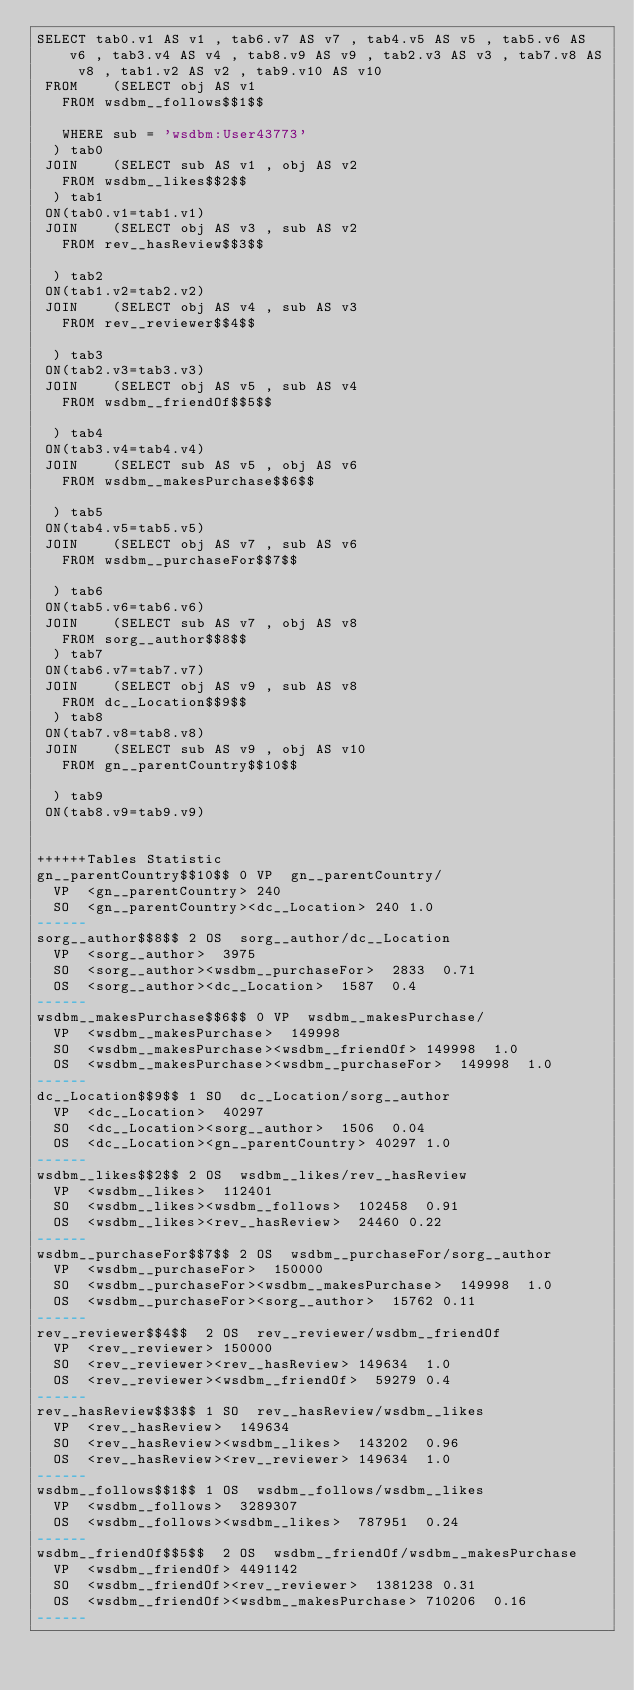<code> <loc_0><loc_0><loc_500><loc_500><_SQL_>SELECT tab0.v1 AS v1 , tab6.v7 AS v7 , tab4.v5 AS v5 , tab5.v6 AS v6 , tab3.v4 AS v4 , tab8.v9 AS v9 , tab2.v3 AS v3 , tab7.v8 AS v8 , tab1.v2 AS v2 , tab9.v10 AS v10 
 FROM    (SELECT obj AS v1 
	 FROM wsdbm__follows$$1$$
	 
	 WHERE sub = 'wsdbm:User43773'
	) tab0
 JOIN    (SELECT sub AS v1 , obj AS v2 
	 FROM wsdbm__likes$$2$$
	) tab1
 ON(tab0.v1=tab1.v1)
 JOIN    (SELECT obj AS v3 , sub AS v2 
	 FROM rev__hasReview$$3$$
	
	) tab2
 ON(tab1.v2=tab2.v2)
 JOIN    (SELECT obj AS v4 , sub AS v3 
	 FROM rev__reviewer$$4$$
	
	) tab3
 ON(tab2.v3=tab3.v3)
 JOIN    (SELECT obj AS v5 , sub AS v4 
	 FROM wsdbm__friendOf$$5$$
	
	) tab4
 ON(tab3.v4=tab4.v4)
 JOIN    (SELECT sub AS v5 , obj AS v6 
	 FROM wsdbm__makesPurchase$$6$$
	
	) tab5
 ON(tab4.v5=tab5.v5)
 JOIN    (SELECT obj AS v7 , sub AS v6 
	 FROM wsdbm__purchaseFor$$7$$
	
	) tab6
 ON(tab5.v6=tab6.v6)
 JOIN    (SELECT sub AS v7 , obj AS v8 
	 FROM sorg__author$$8$$
	) tab7
 ON(tab6.v7=tab7.v7)
 JOIN    (SELECT obj AS v9 , sub AS v8 
	 FROM dc__Location$$9$$
	) tab8
 ON(tab7.v8=tab8.v8)
 JOIN    (SELECT sub AS v9 , obj AS v10 
	 FROM gn__parentCountry$$10$$
	
	) tab9
 ON(tab8.v9=tab9.v9)


++++++Tables Statistic
gn__parentCountry$$10$$	0	VP	gn__parentCountry/
	VP	<gn__parentCountry>	240
	SO	<gn__parentCountry><dc__Location>	240	1.0
------
sorg__author$$8$$	2	OS	sorg__author/dc__Location
	VP	<sorg__author>	3975
	SO	<sorg__author><wsdbm__purchaseFor>	2833	0.71
	OS	<sorg__author><dc__Location>	1587	0.4
------
wsdbm__makesPurchase$$6$$	0	VP	wsdbm__makesPurchase/
	VP	<wsdbm__makesPurchase>	149998
	SO	<wsdbm__makesPurchase><wsdbm__friendOf>	149998	1.0
	OS	<wsdbm__makesPurchase><wsdbm__purchaseFor>	149998	1.0
------
dc__Location$$9$$	1	SO	dc__Location/sorg__author
	VP	<dc__Location>	40297
	SO	<dc__Location><sorg__author>	1506	0.04
	OS	<dc__Location><gn__parentCountry>	40297	1.0
------
wsdbm__likes$$2$$	2	OS	wsdbm__likes/rev__hasReview
	VP	<wsdbm__likes>	112401
	SO	<wsdbm__likes><wsdbm__follows>	102458	0.91
	OS	<wsdbm__likes><rev__hasReview>	24460	0.22
------
wsdbm__purchaseFor$$7$$	2	OS	wsdbm__purchaseFor/sorg__author
	VP	<wsdbm__purchaseFor>	150000
	SO	<wsdbm__purchaseFor><wsdbm__makesPurchase>	149998	1.0
	OS	<wsdbm__purchaseFor><sorg__author>	15762	0.11
------
rev__reviewer$$4$$	2	OS	rev__reviewer/wsdbm__friendOf
	VP	<rev__reviewer>	150000
	SO	<rev__reviewer><rev__hasReview>	149634	1.0
	OS	<rev__reviewer><wsdbm__friendOf>	59279	0.4
------
rev__hasReview$$3$$	1	SO	rev__hasReview/wsdbm__likes
	VP	<rev__hasReview>	149634
	SO	<rev__hasReview><wsdbm__likes>	143202	0.96
	OS	<rev__hasReview><rev__reviewer>	149634	1.0
------
wsdbm__follows$$1$$	1	OS	wsdbm__follows/wsdbm__likes
	VP	<wsdbm__follows>	3289307
	OS	<wsdbm__follows><wsdbm__likes>	787951	0.24
------
wsdbm__friendOf$$5$$	2	OS	wsdbm__friendOf/wsdbm__makesPurchase
	VP	<wsdbm__friendOf>	4491142
	SO	<wsdbm__friendOf><rev__reviewer>	1381238	0.31
	OS	<wsdbm__friendOf><wsdbm__makesPurchase>	710206	0.16
------
</code> 